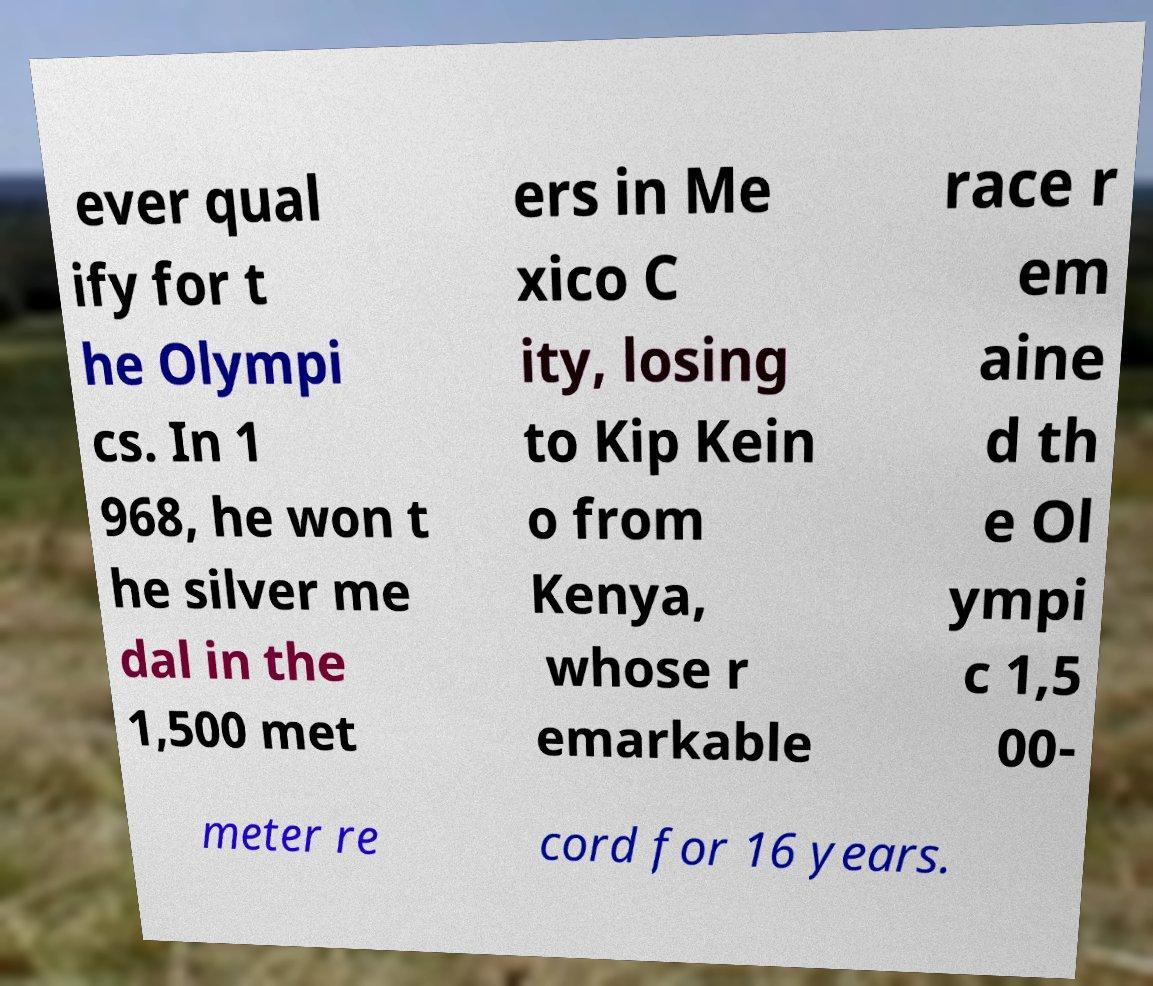Could you assist in decoding the text presented in this image and type it out clearly? ever qual ify for t he Olympi cs. In 1 968, he won t he silver me dal in the 1,500 met ers in Me xico C ity, losing to Kip Kein o from Kenya, whose r emarkable race r em aine d th e Ol ympi c 1,5 00- meter re cord for 16 years. 